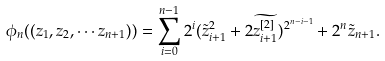Convert formula to latex. <formula><loc_0><loc_0><loc_500><loc_500>\phi _ { n } ( ( z _ { 1 } , z _ { 2 } , \cdots z _ { n + 1 } ) ) = \sum _ { i = 0 } ^ { n - 1 } 2 ^ { i } ( \tilde { z } _ { i + 1 } ^ { 2 } + 2 \widetilde { z _ { i + 1 } ^ { [ 2 ] } } ) ^ { 2 ^ { n - i - 1 } } + 2 ^ { n } \tilde { z } _ { n + 1 } .</formula> 